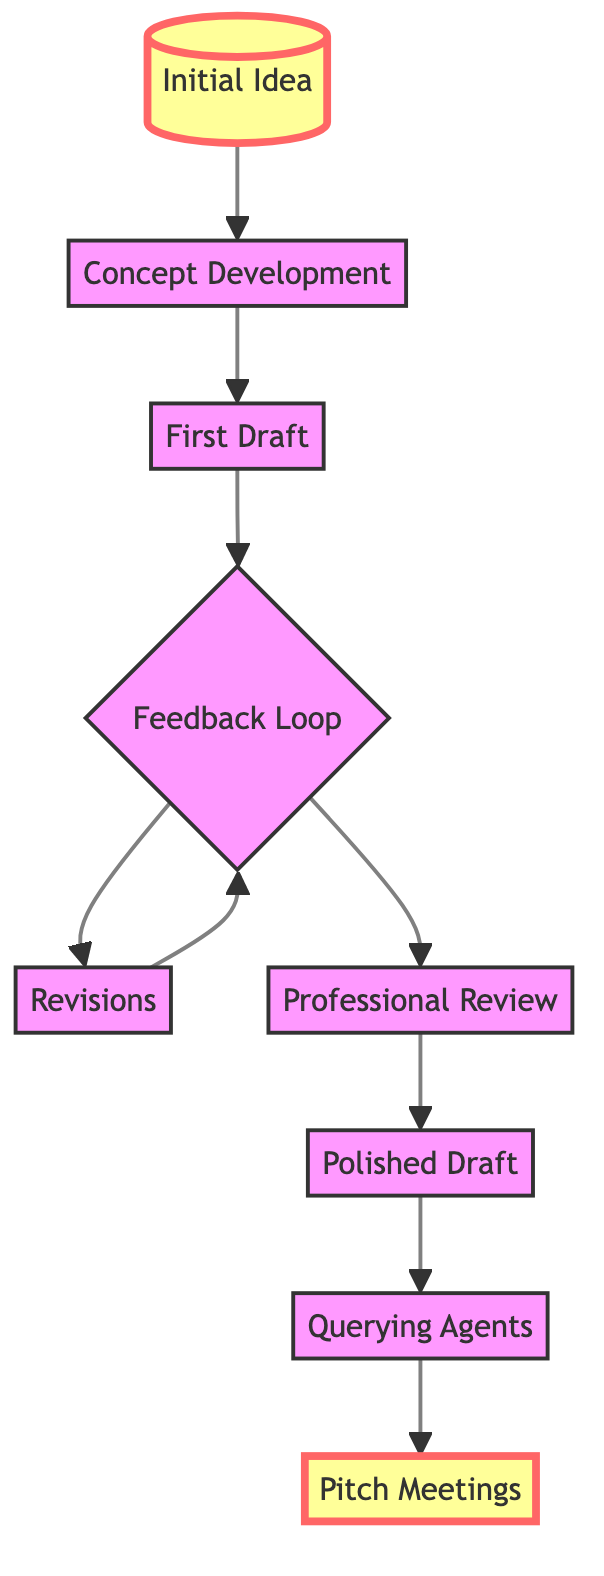What is the first stage in the journey? The first stage listed in the flow chart is the "Initial Idea," which represents the starting point of the journey for a screenwriter.
Answer: Initial Idea How many stages are included in the journey? The diagram has a total of nine distinct stages, as indicated by the different nodes from bottom to top.
Answer: 9 What stage follows "First Draft"? According to the flow chart, the stage that follows "First Draft" is the "Feedback Loop," where the script undergoes evaluation by peers for constructive feedback.
Answer: Feedback Loop At which stage does the writer reach out to literary agents? The stage at which the writer reaches out to literary agents is "Querying Agents," where they send query letters along with the polished script.
Answer: Querying Agents What is the relationship between "Revisions" and "Feedback Loop"? The "Revisions" stage follows the "Feedback Loop," and there is a loop that indicates revisions can send feedback back to the "Feedback Loop," meaning this process is iterative.
Answer: Iterative relationship How many times does the "Feedback Loop" stage occur before the "Professional Review"? The "Feedback Loop" stage is mentioned as a one-time step prior to moving to "Professional Review," implying back and forth revisions occur but the flow to review happens once.
Answer: 1 What type of feedback do writers typically seek during the "Feedback Loop"? During the "Feedback Loop," writers seek constructive criticism from industry friends, mentors, and fellow screenwriters, focusing on refining their work.
Answer: Constructive criticism What is the last stage in the journey? The final stage in the diagram's flow chart is "Pitch Meetings," where the completed script is presented to producers and executives.
Answer: Pitch Meetings 